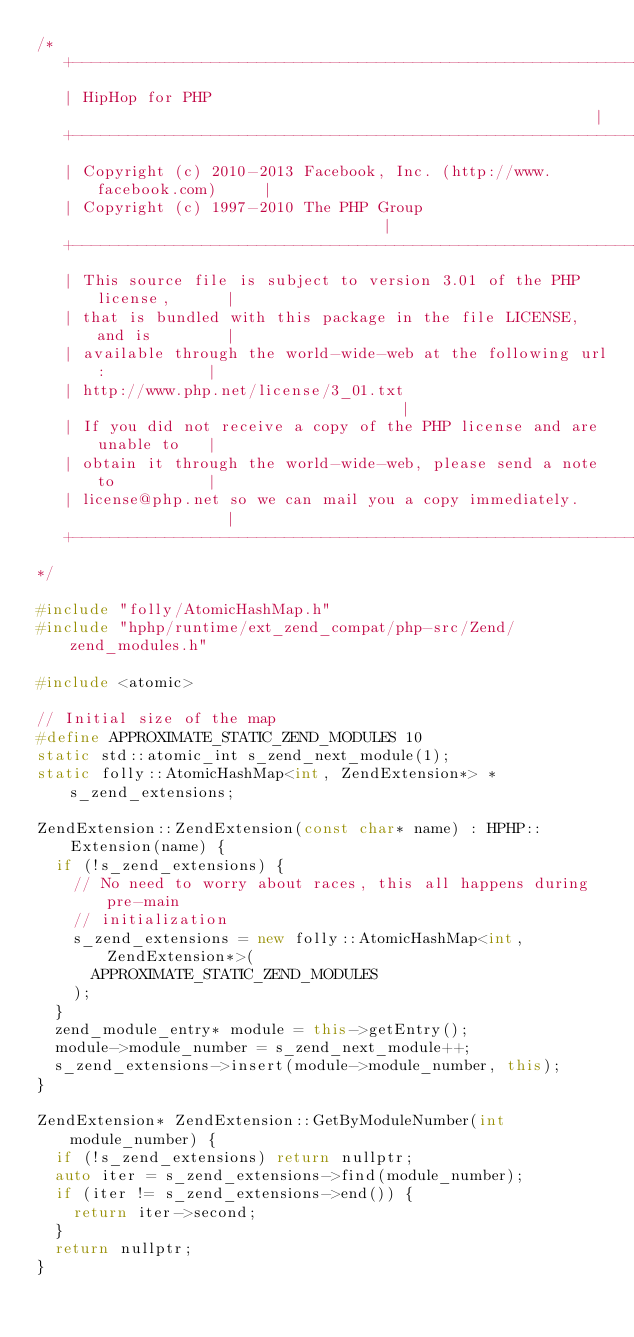Convert code to text. <code><loc_0><loc_0><loc_500><loc_500><_C++_>/*
   +----------------------------------------------------------------------+
   | HipHop for PHP                                                       |
   +----------------------------------------------------------------------+
   | Copyright (c) 2010-2013 Facebook, Inc. (http://www.facebook.com)     |
   | Copyright (c) 1997-2010 The PHP Group                                |
   +----------------------------------------------------------------------+
   | This source file is subject to version 3.01 of the PHP license,      |
   | that is bundled with this package in the file LICENSE, and is        |
   | available through the world-wide-web at the following url:           |
   | http://www.php.net/license/3_01.txt                                  |
   | If you did not receive a copy of the PHP license and are unable to   |
   | obtain it through the world-wide-web, please send a note to          |
   | license@php.net so we can mail you a copy immediately.               |
   +----------------------------------------------------------------------+
*/

#include "folly/AtomicHashMap.h"
#include "hphp/runtime/ext_zend_compat/php-src/Zend/zend_modules.h"

#include <atomic>

// Initial size of the map
#define APPROXIMATE_STATIC_ZEND_MODULES 10
static std::atomic_int s_zend_next_module(1);
static folly::AtomicHashMap<int, ZendExtension*> *s_zend_extensions;

ZendExtension::ZendExtension(const char* name) : HPHP::Extension(name) {
  if (!s_zend_extensions) {
    // No need to worry about races, this all happens during pre-main
    // initialization
    s_zend_extensions = new folly::AtomicHashMap<int, ZendExtension*>(
      APPROXIMATE_STATIC_ZEND_MODULES
    );
  }
  zend_module_entry* module = this->getEntry();
  module->module_number = s_zend_next_module++;
  s_zend_extensions->insert(module->module_number, this);
}

ZendExtension* ZendExtension::GetByModuleNumber(int module_number) {
  if (!s_zend_extensions) return nullptr;
  auto iter = s_zend_extensions->find(module_number);
  if (iter != s_zend_extensions->end()) {
    return iter->second;
  }
  return nullptr;
}
</code> 